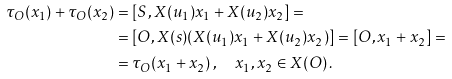Convert formula to latex. <formula><loc_0><loc_0><loc_500><loc_500>\tau _ { O } ( x _ { 1 } ) + \tau _ { O } ( x _ { 2 } ) & = [ S , X ( u _ { 1 } ) x _ { 1 } + X ( u _ { 2 } ) x _ { 2 } ] = \\ & = [ O , X ( s ) ( X ( u _ { 1 } ) x _ { 1 } + X ( u _ { 2 } ) x _ { 2 } ) ] = [ O , x _ { 1 } + x _ { 2 } ] = \\ & = \tau _ { O } ( x _ { 1 } + x _ { 2 } ) \, , \quad x _ { 1 } , x _ { 2 } \in X ( O ) \, .</formula> 